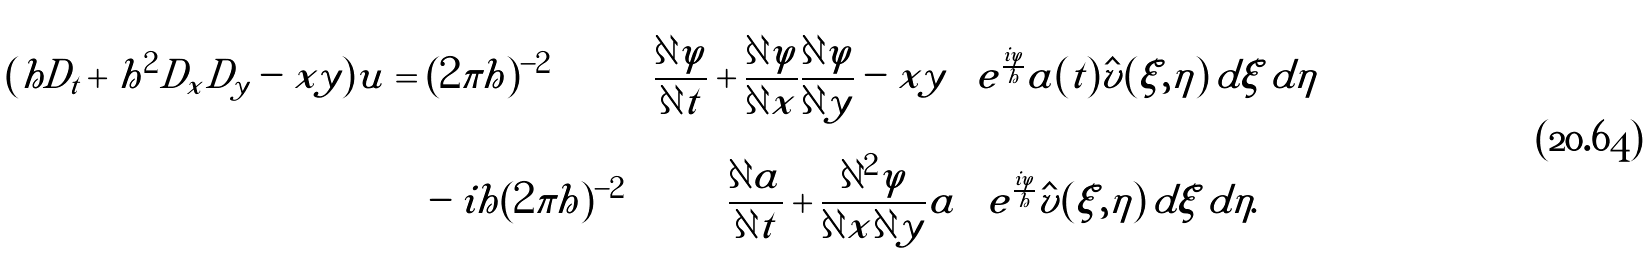Convert formula to latex. <formula><loc_0><loc_0><loc_500><loc_500>( h D _ { t } + h ^ { 2 } D _ { x } D _ { y } - x y ) u & = ( 2 \pi h ) ^ { - 2 } \iint \left [ \frac { \partial \varphi } { \partial t } + \frac { \partial \varphi } { \partial x } \frac { \partial \varphi } { \partial y } - x y \right ] e ^ { \frac { i \varphi } { h } } a ( t ) \hat { v } ( \xi , \eta ) \, d \xi \, d \eta \\ & \quad - i h ( 2 \pi h ) ^ { - 2 } \iint \left [ \frac { \partial a } { \partial t } + \frac { \partial ^ { 2 } \varphi } { \partial x \partial y } a \right ] e ^ { \frac { i \varphi } { h } } \hat { v } ( \xi , \eta ) \, d \xi \, d \eta .</formula> 